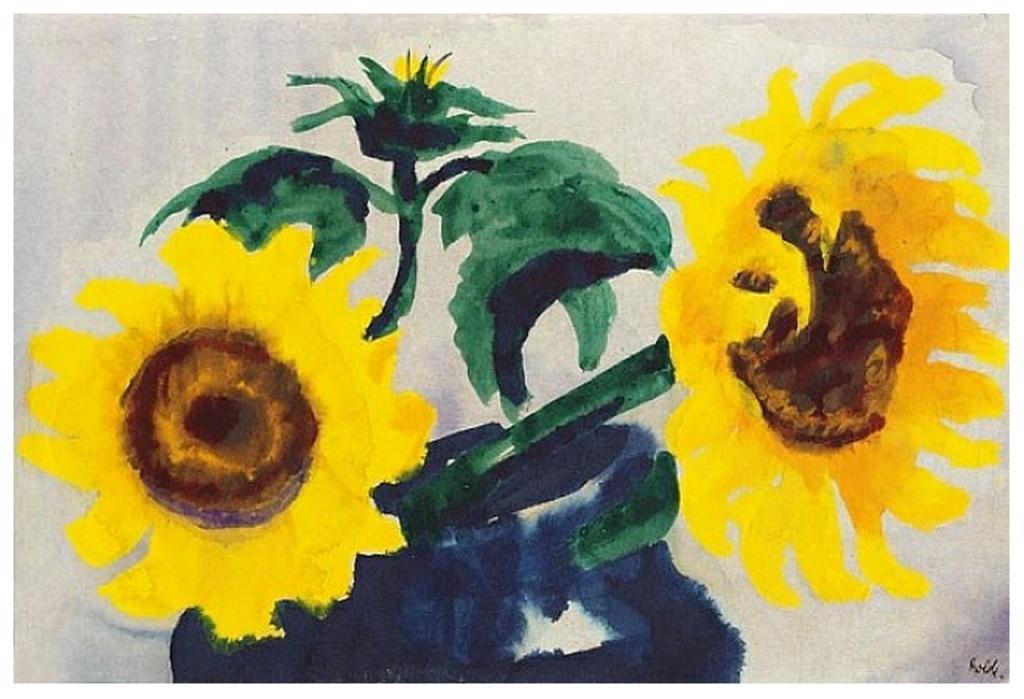Please provide a concise description of this image. This image consists of a painting. In which we can see sunflowers along with leaves. 